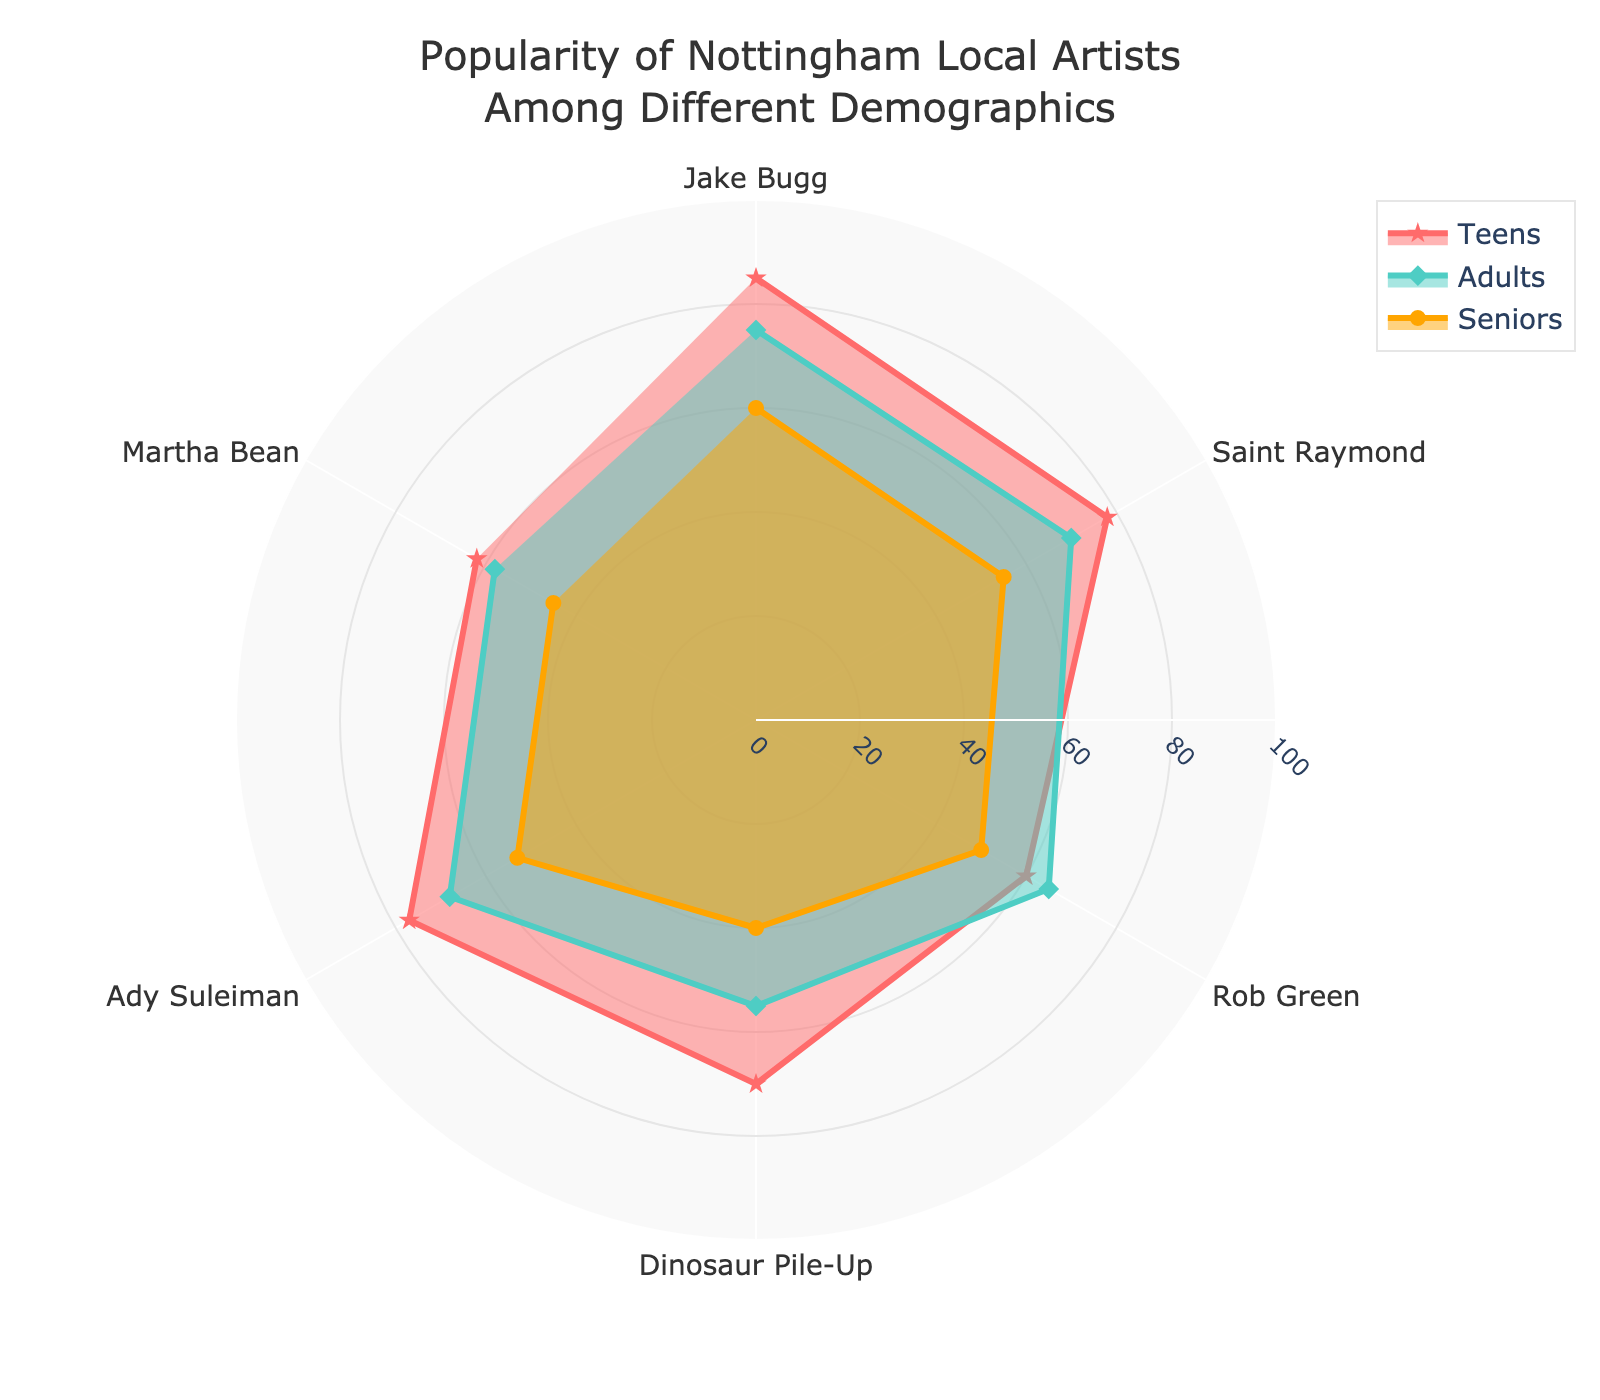What's the title of the figure? The title can be found at the top of the chart. It is usually a concise description of the chart's content.
Answer: Popularity of Nottingham Local Artists Among Different Demographics How many artists are featured in the radar chart? Count the number of categories listed around the chart. Each category represents an artist.
Answer: 6 What is the color associated with the Teens demographic? Identify the color of the line and fill for the Teens group.
Answer: Red (#FF6B6B) Which demographic group has the lowest score for Dinosaur Pile-Up? Locate the scores for Dinosaur Pile-Up and identify the lowest one among the demographics.
Answer: Seniors What is the range of the radial axis? Observe the radial axis and look for the minimum and maximum values.
Answer: 0 to 100 Which artist is the most popular among Teens? Identify the highest value in the Teens group and match it to the corresponding artist.
Answer: Jake Bugg What's the average popularity score of Ady Suleiman across all demographics? Calculate the average by summing the scores (77 for Teens, 68 for Adults, and 53 for Seniors) and dividing by the number of demographics (3).
Answer: (77+68+53)/3 = 66 For which artist do Adults and Seniors have the biggest difference in popularity scores? Calculate the score differences between Adults and Seniors for each artist and identify the largest one.
Answer: Jake Bugg (75 - 60 = 15) How does the popularity of Martha Bean compare between Teens and Adults? Compare the scores directly: Teens score and Adults score for Martha Bean.
Answer: Teens: 62, Adults: 58 Which demographic shows the least variation in artist popularity? Observe the spreads of the values for each demographic group and identify the one with the least variation.
Answer: Seniors 